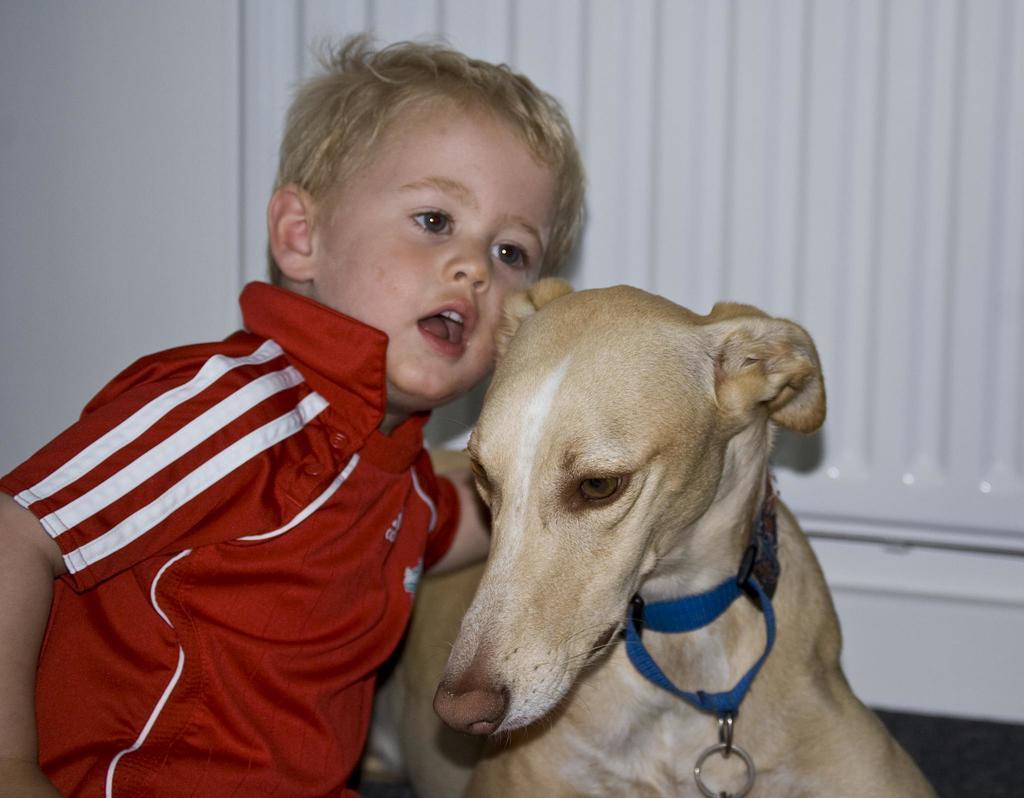In one or two sentences, can you explain what this image depicts? There is a kid sitting beside the dog and the background is white in color. 